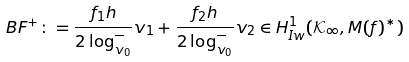Convert formula to latex. <formula><loc_0><loc_0><loc_500><loc_500>B F ^ { + } \colon = \frac { f _ { 1 } h } { 2 \log _ { v _ { 0 } } ^ { - } } v _ { 1 } + \frac { f _ { 2 } h } { 2 \log _ { v _ { 0 } } ^ { - } } v _ { 2 } \in H ^ { 1 } _ { I w } ( \mathcal { K } _ { \infty } , M ( f ) ^ { * } )</formula> 